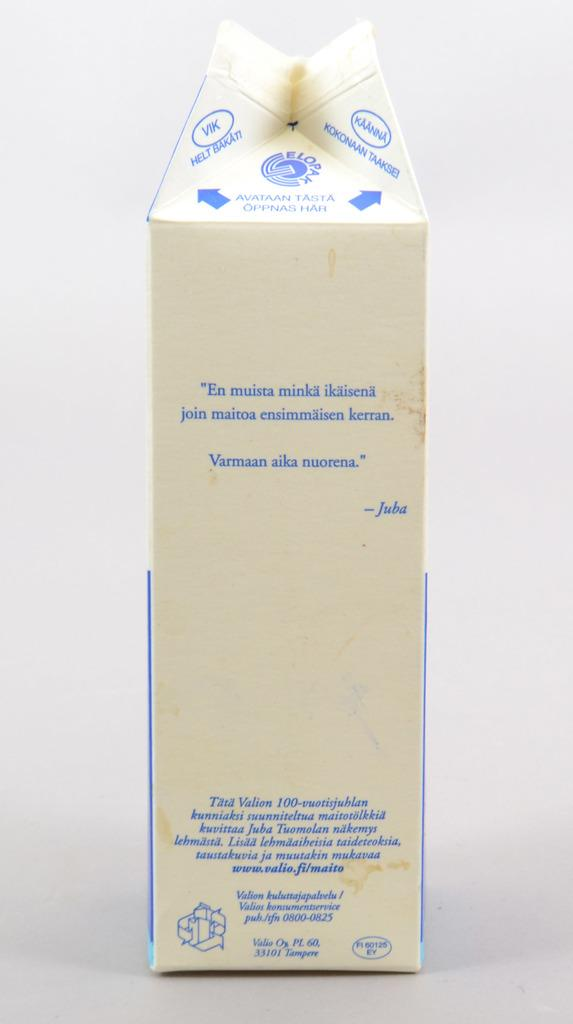What is the main subject in the center of the image? There is a carton in the center of the image. What type of bun is being used to hold the needle in the image? There is no bun or needle present in the image; it only features a carton. What song is being played in the background of the image? There is no song or audio element present in the image; it only features a carton. 